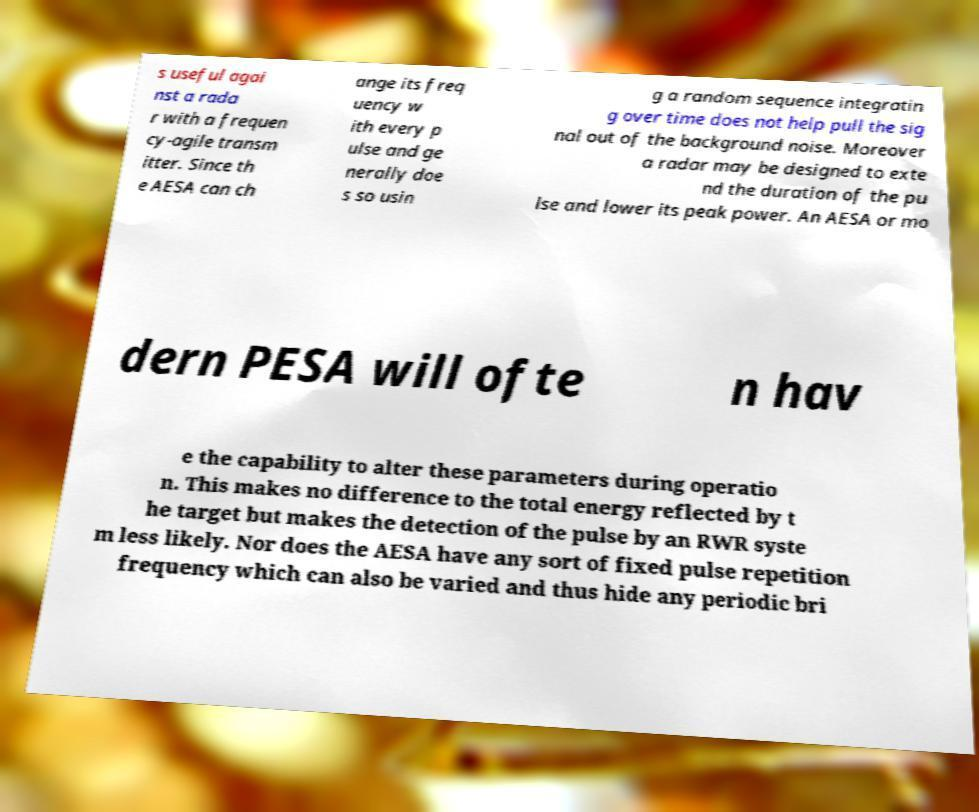Can you read and provide the text displayed in the image?This photo seems to have some interesting text. Can you extract and type it out for me? s useful agai nst a rada r with a frequen cy-agile transm itter. Since th e AESA can ch ange its freq uency w ith every p ulse and ge nerally doe s so usin g a random sequence integratin g over time does not help pull the sig nal out of the background noise. Moreover a radar may be designed to exte nd the duration of the pu lse and lower its peak power. An AESA or mo dern PESA will ofte n hav e the capability to alter these parameters during operatio n. This makes no difference to the total energy reflected by t he target but makes the detection of the pulse by an RWR syste m less likely. Nor does the AESA have any sort of fixed pulse repetition frequency which can also be varied and thus hide any periodic bri 